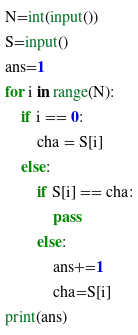Convert code to text. <code><loc_0><loc_0><loc_500><loc_500><_Python_>N=int(input())
S=input()
ans=1
for i in range(N):
    if i == 0:
        cha = S[i]
    else:
        if S[i] == cha:
            pass
        else:
            ans+=1
            cha=S[i]
print(ans)</code> 